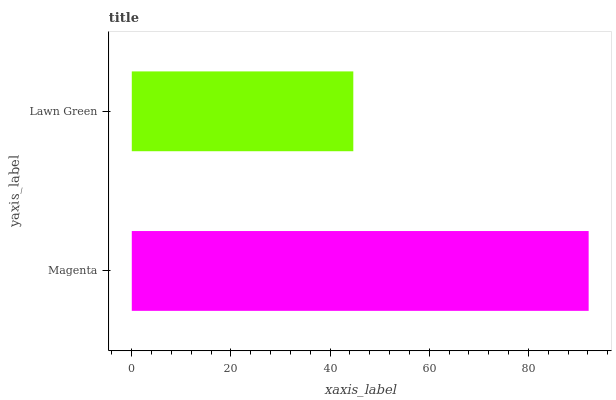Is Lawn Green the minimum?
Answer yes or no. Yes. Is Magenta the maximum?
Answer yes or no. Yes. Is Lawn Green the maximum?
Answer yes or no. No. Is Magenta greater than Lawn Green?
Answer yes or no. Yes. Is Lawn Green less than Magenta?
Answer yes or no. Yes. Is Lawn Green greater than Magenta?
Answer yes or no. No. Is Magenta less than Lawn Green?
Answer yes or no. No. Is Magenta the high median?
Answer yes or no. Yes. Is Lawn Green the low median?
Answer yes or no. Yes. Is Lawn Green the high median?
Answer yes or no. No. Is Magenta the low median?
Answer yes or no. No. 